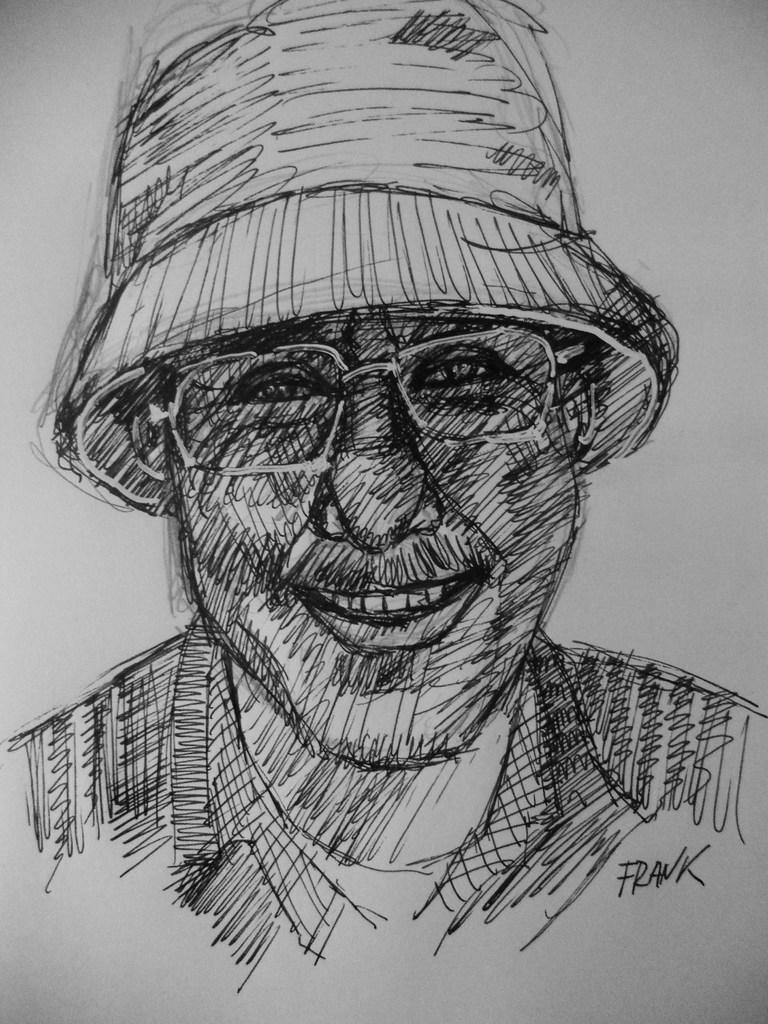What is the main subject of the image? There is a painting in the image. What is depicted in the painting? The painting depicts a person. What accessories is the person in the painting wearing? The person in the painting is wearing spectacles and a cap. What type of potato is being used in the operation depicted in the painting? There is no operation or potato present in the image; it features a painting of a person wearing spectacles and a cap. 